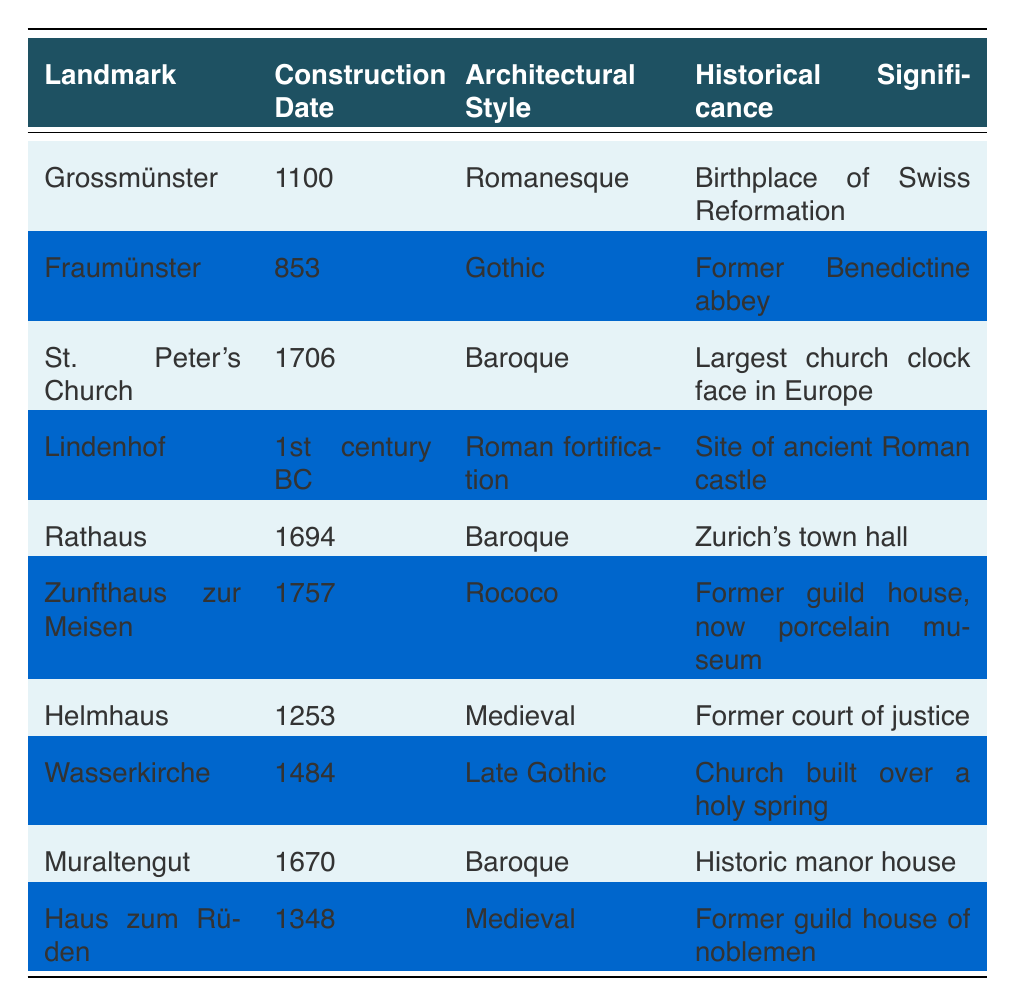What is the construction date of the Grossmünster? The table lists the construction date for the Grossmünster as 1100, which can be found directly in the corresponding row under the "Construction Date" column.
Answer: 1100 Which architectural style does the Fraumünster represent? From the table, the Fraumünster is categorized under the "Architectural Style" column as Gothic, which is clearly stated in its corresponding row.
Answer: Gothic Is the Rathaus older than the Zunfthaus zur Meisen? To determine this, we compare the construction dates: Rathaus is listed as 1694 and Zunfthaus zur Meisen as 1757. Since 1694 is earlier than 1757, the answer is yes.
Answer: Yes How many landmarks were constructed in the 17th century or later? The landmarks constructed in the 17th century or later include St. Peter's Church (1706), Rathaus (1694), Zunfthaus zur Meisen (1757), and Muraltengut (1670). Among these, St. Peter's Church, Rathaus, and Zunfthaus zur Meisen are 17th century or later so there are 3 landmarks.
Answer: 3 What is the historical significance of the Wasserkirche? The historical significance of the Wasserkirche is mentioned in the table as being built over a holy spring, which is specified in its row under "Historical Significance".
Answer: Church built over a holy spring Which architectural style is the oldest in this table? The oldest architectural style in the table is Roman fortification, which relates to the Lindenhof constructed in the 1st century BC. This is found by checking the dates and noting that the Roman fortification is earlier than any other listed styles and dates.
Answer: Roman fortification Are any landmarks listed as being medieval? Checking the table reveals two landmarks identified as Medieval: Helmhaus (1253) and Haus zum Rüden (1348). Thus, the answer is yes.
Answer: Yes Which landmark has the largest church clock face in Europe? According to the table, St. Peter's Church is noted for having the largest church clock face in Europe, as indicated in the "Historical Significance" column of its row.
Answer: St. Peter's Church Which landmark was originally a Benedictine abbey? The table identifies the Fraumünster as the former Benedictine abbey in the "Historical Significance" column, allowing us to answer directly from the information presented.
Answer: Fraumünster 